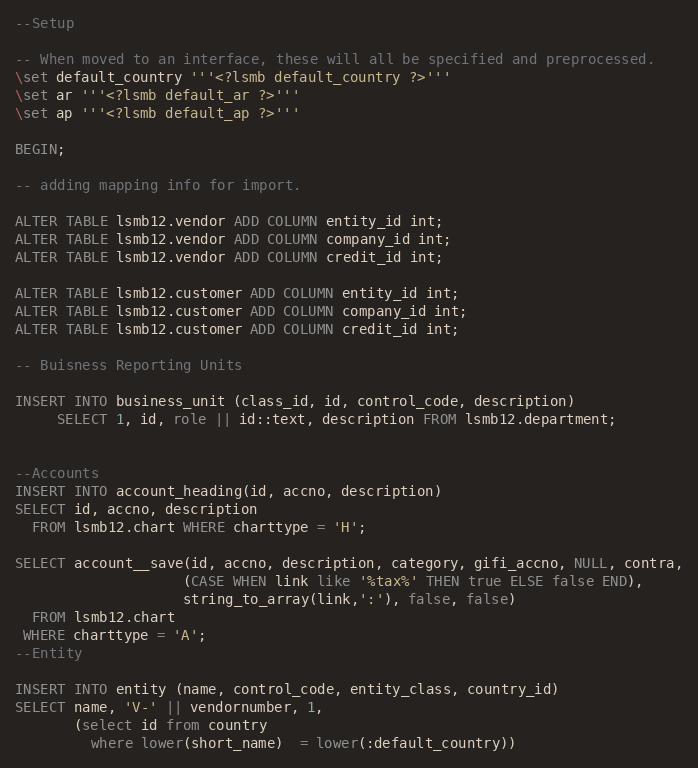Convert code to text. <code><loc_0><loc_0><loc_500><loc_500><_SQL_>--Setup

-- When moved to an interface, these will all be specified and preprocessed.
\set default_country '''<?lsmb default_country ?>'''
\set ar '''<?lsmb default_ar ?>'''
\set ap '''<?lsmb default_ap ?>'''

BEGIN;

-- adding mapping info for import.

ALTER TABLE lsmb12.vendor ADD COLUMN entity_id int;
ALTER TABLE lsmb12.vendor ADD COLUMN company_id int;
ALTER TABLE lsmb12.vendor ADD COLUMN credit_id int;

ALTER TABLE lsmb12.customer ADD COLUMN entity_id int;
ALTER TABLE lsmb12.customer ADD COLUMN company_id int;
ALTER TABLE lsmb12.customer ADD COLUMN credit_id int;

-- Buisness Reporting Units

INSERT INTO business_unit (class_id, id, control_code, description)
     SELECT 1, id, role || id::text, description FROM lsmb12.department;


--Accounts
INSERT INTO account_heading(id, accno, description)
SELECT id, accno, description
  FROM lsmb12.chart WHERE charttype = 'H';

SELECT account__save(id, accno, description, category, gifi_accno, NULL, contra,
                    (CASE WHEN link like '%tax%' THEN true ELSE false END),
                    string_to_array(link,':'), false, false)
  FROM lsmb12.chart
 WHERE charttype = 'A';
--Entity

INSERT INTO entity (name, control_code, entity_class, country_id)
SELECT name, 'V-' || vendornumber, 1,
       (select id from country
         where lower(short_name)  = lower(:default_country))</code> 